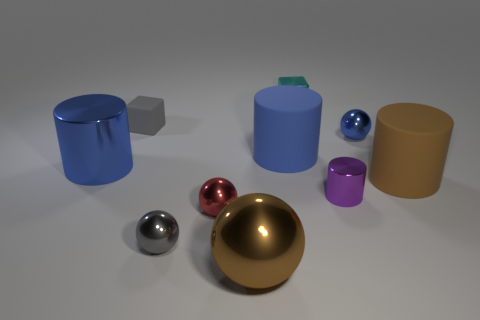Are the small gray thing that is behind the small metallic cylinder and the large blue cylinder that is to the right of the small gray shiny object made of the same material?
Offer a very short reply. Yes. There is a tiny gray thing in front of the red metal ball; is its shape the same as the brown shiny object that is in front of the small cyan thing?
Make the answer very short. Yes. Is the number of big things in front of the purple metal cylinder less than the number of big blue things?
Your answer should be very brief. Yes. How many tiny objects are the same color as the tiny rubber block?
Your answer should be compact. 1. What is the size of the metallic ball that is right of the small purple metal thing?
Ensure brevity in your answer.  Small. The cyan metal thing that is behind the big cylinder in front of the big thing that is to the left of the small red shiny thing is what shape?
Provide a short and direct response. Cube. The tiny shiny object that is to the left of the purple cylinder and to the right of the big brown shiny ball has what shape?
Provide a succinct answer. Cube. Is there a rubber cylinder of the same size as the brown sphere?
Provide a short and direct response. Yes. Is the shape of the big object in front of the large brown cylinder the same as  the red shiny thing?
Your answer should be compact. Yes. Do the small cyan shiny thing and the tiny gray shiny thing have the same shape?
Make the answer very short. No. 